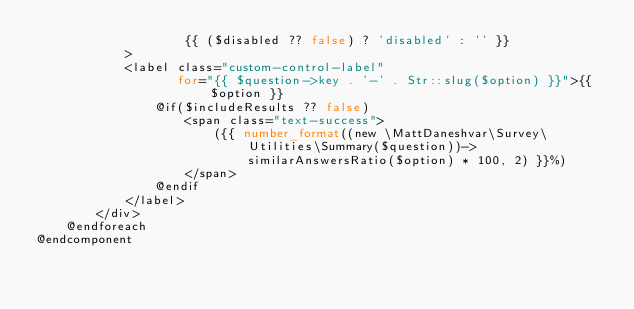Convert code to text. <code><loc_0><loc_0><loc_500><loc_500><_PHP_>                    {{ ($disabled ?? false) ? 'disabled' : '' }}
            >
            <label class="custom-control-label"
                   for="{{ $question->key . '-' . Str::slug($option) }}">{{ $option }}
                @if($includeResults ?? false)
                    <span class="text-success">
                        ({{ number_format((new \MattDaneshvar\Survey\Utilities\Summary($question))->similarAnswersRatio($option) * 100, 2) }}%)
                    </span>
                @endif
            </label>
        </div>
    @endforeach
@endcomponent</code> 